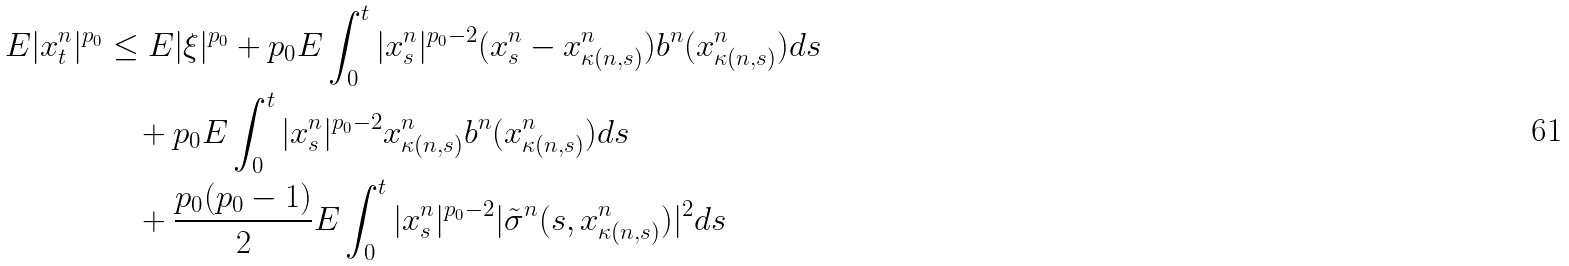<formula> <loc_0><loc_0><loc_500><loc_500>E | x _ { t } ^ { n } | ^ { p _ { 0 } } & \leq E | \xi | ^ { p _ { 0 } } + p _ { 0 } E \int _ { 0 } ^ { t } | x _ { s } ^ { n } | ^ { p _ { 0 } - 2 } ( x _ { s } ^ { n } - x _ { \kappa ( n , s ) } ^ { n } ) b ^ { n } ( x _ { \kappa ( n , s ) } ^ { n } ) d s \\ & \quad + p _ { 0 } E \int _ { 0 } ^ { t } | x _ { s } ^ { n } | ^ { p _ { 0 } - 2 } x _ { \kappa ( n , s ) } ^ { n } b ^ { n } ( x _ { \kappa ( n , s ) } ^ { n } ) d s \\ & \quad + \frac { p _ { 0 } ( p _ { 0 } - 1 ) } { 2 } E \int _ { 0 } ^ { t } | x _ { s } ^ { n } | ^ { p _ { 0 } - 2 } | \tilde { \sigma } ^ { n } ( s , x _ { \kappa ( n , s ) } ^ { n } ) | ^ { 2 } d s</formula> 